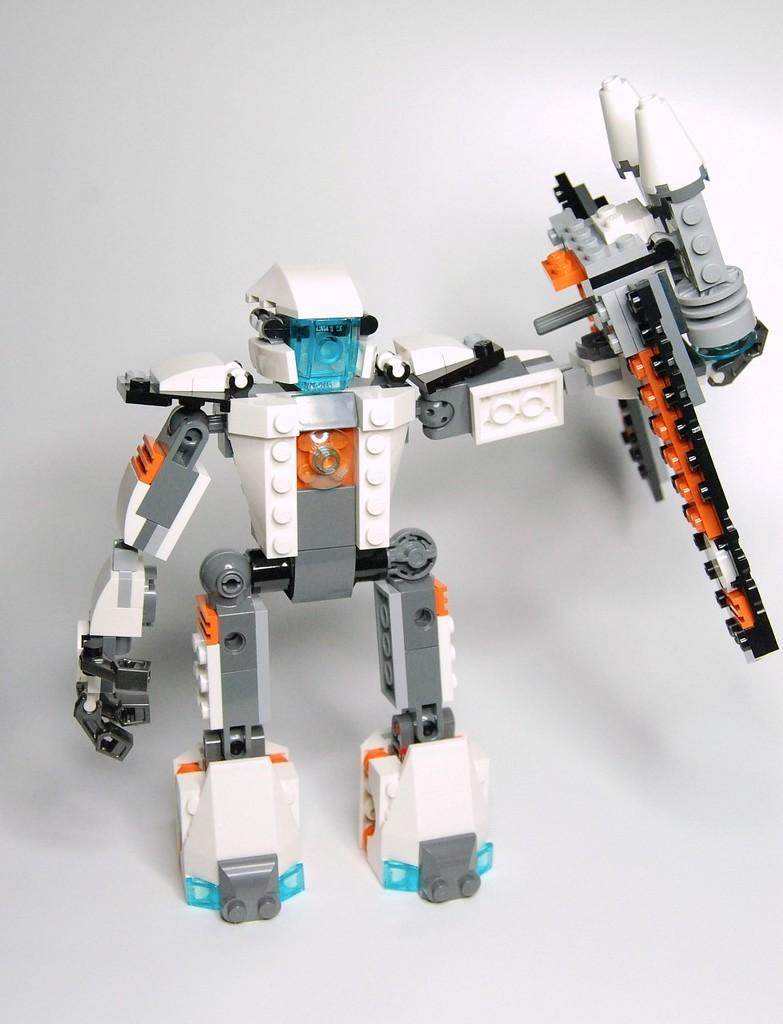What is the main subject in the middle of the image? There is a toy in the middle of the image. What type of store is selling the toy in the image? There is no information about a store in the image, as it only features a toy in the middle. 